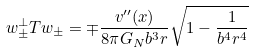Convert formula to latex. <formula><loc_0><loc_0><loc_500><loc_500>w _ { \pm } ^ { \perp } T w _ { \pm } = \mp \frac { v ^ { \prime \prime } ( x ) } { 8 \pi G _ { N } b ^ { 3 } r } \sqrt { 1 - \frac { 1 } { b ^ { 4 } r ^ { 4 } } }</formula> 